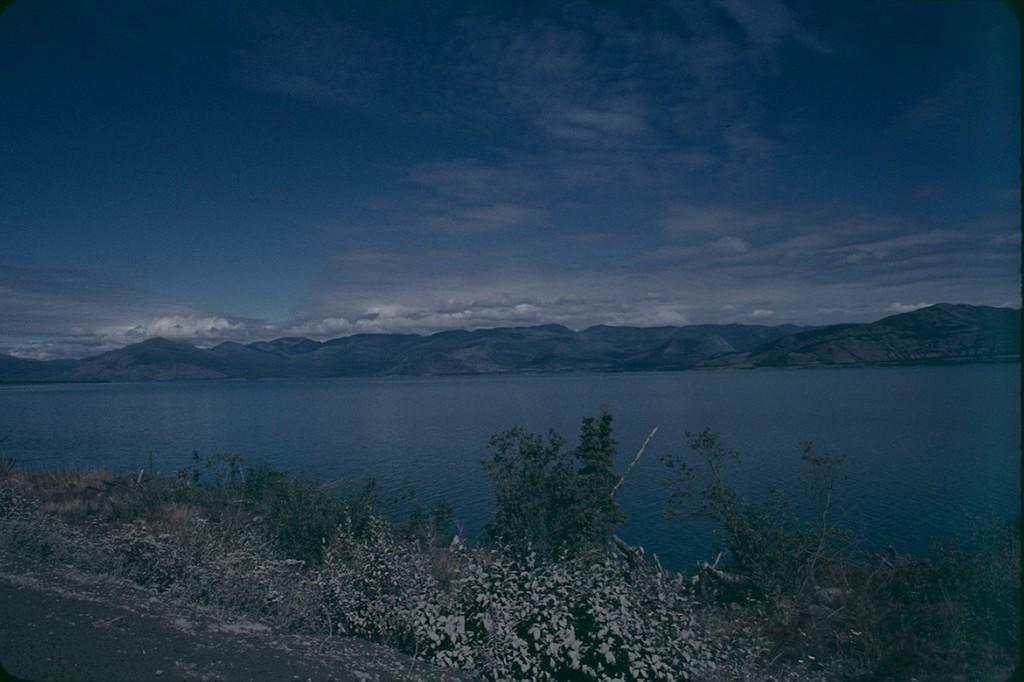Please provide a concise description of this image. In this picture we can see water and on left side of the water we have mountains and above the mountains sky with clouds and on right side we can see road with trees beside to the road. 